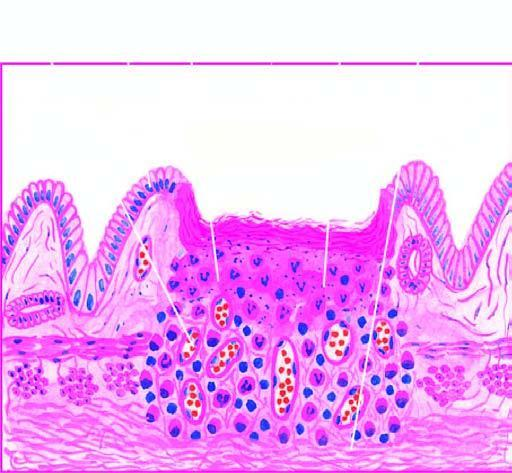what are illustrated in the diagram?
Answer the question using a single word or phrase. Histologic zones of the ulcer 